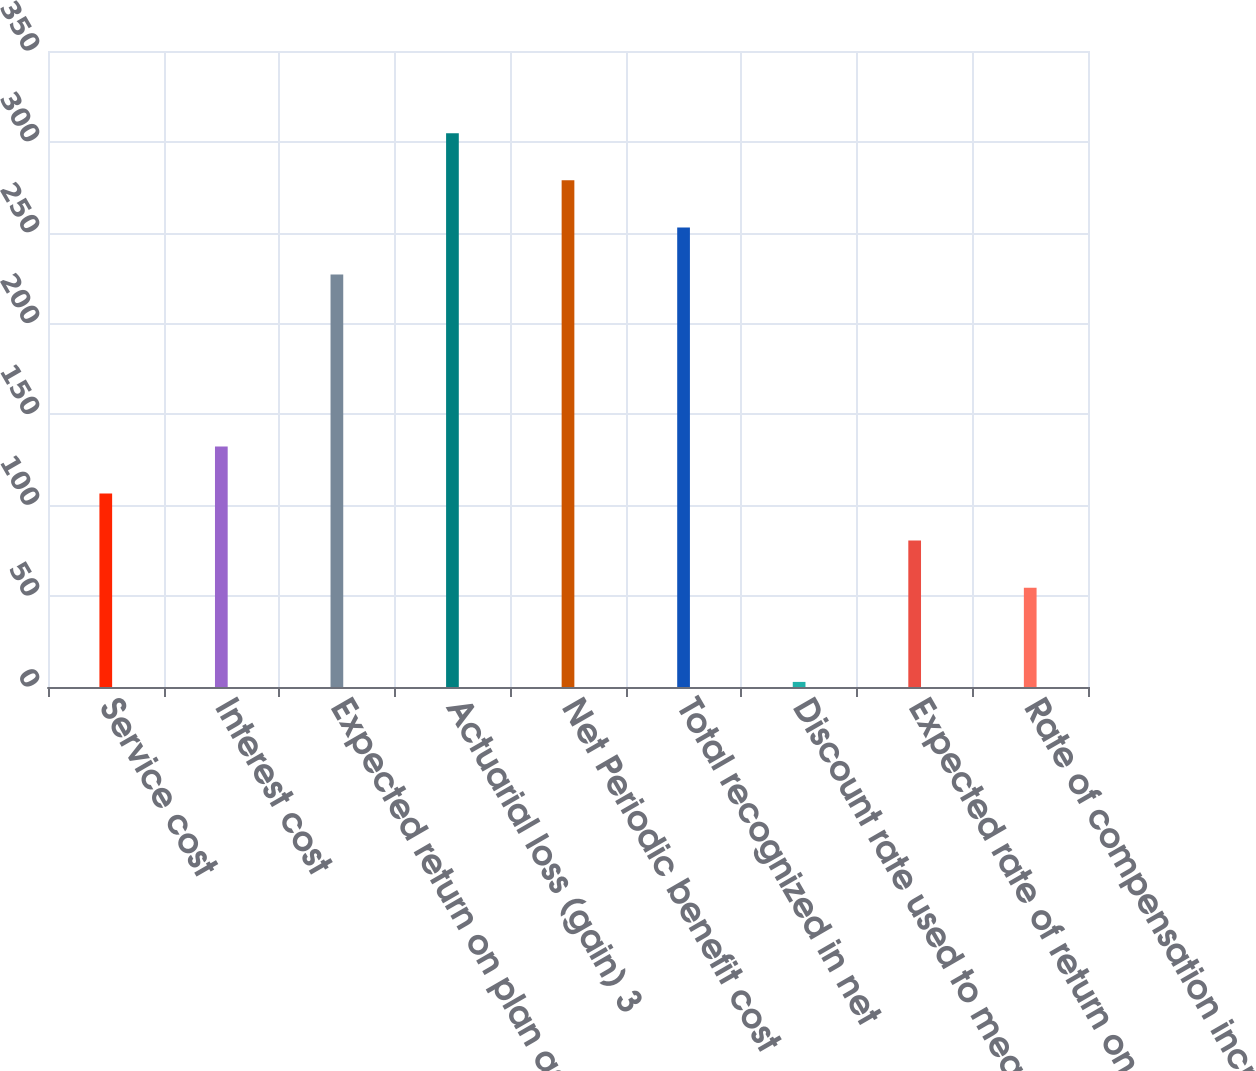Convert chart. <chart><loc_0><loc_0><loc_500><loc_500><bar_chart><fcel>Service cost<fcel>Interest cost<fcel>Expected return on plan assets<fcel>Actuarial loss (gain) 3<fcel>Net Periodic benefit cost<fcel>Total recognized in net<fcel>Discount rate used to measure<fcel>Expected rate of return on<fcel>Rate of compensation increase<nl><fcel>106.48<fcel>132.4<fcel>227<fcel>304.76<fcel>278.84<fcel>252.92<fcel>2.8<fcel>80.56<fcel>54.64<nl></chart> 